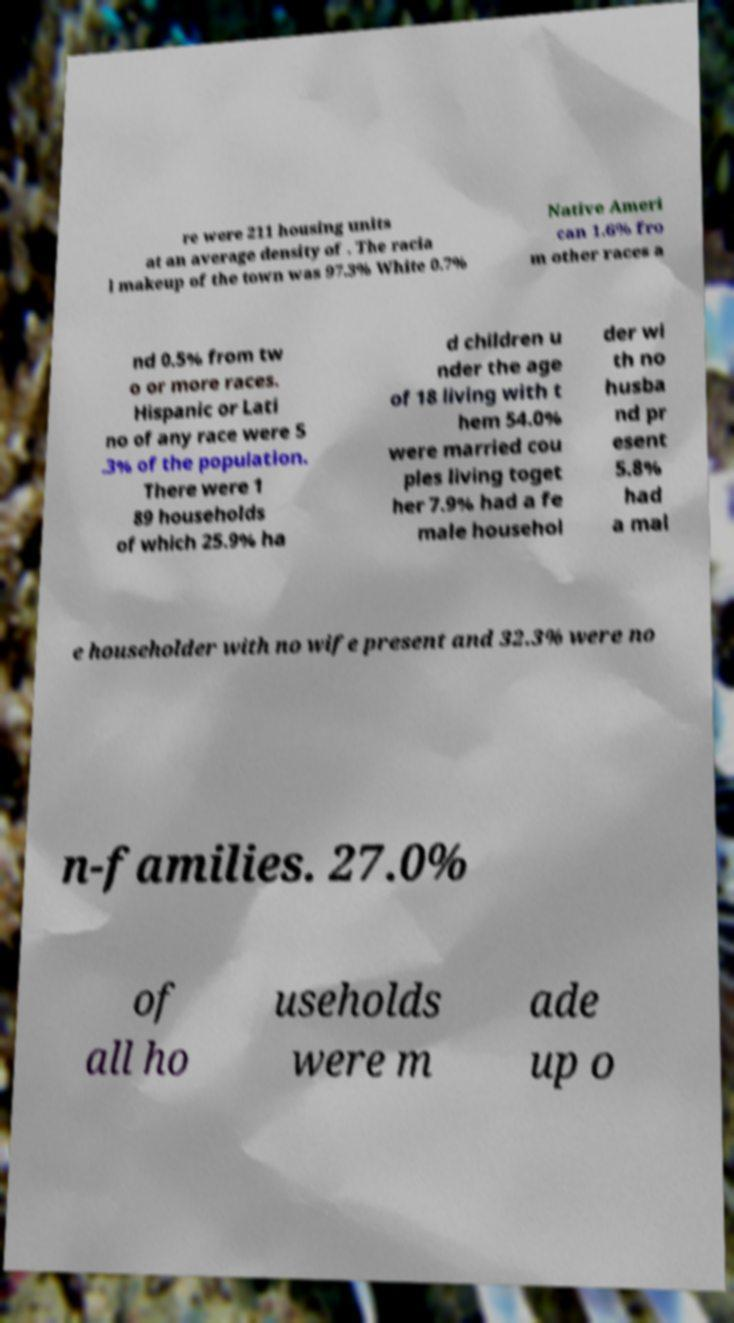There's text embedded in this image that I need extracted. Can you transcribe it verbatim? re were 211 housing units at an average density of . The racia l makeup of the town was 97.3% White 0.7% Native Ameri can 1.6% fro m other races a nd 0.5% from tw o or more races. Hispanic or Lati no of any race were 5 .3% of the population. There were 1 89 households of which 25.9% ha d children u nder the age of 18 living with t hem 54.0% were married cou ples living toget her 7.9% had a fe male househol der wi th no husba nd pr esent 5.8% had a mal e householder with no wife present and 32.3% were no n-families. 27.0% of all ho useholds were m ade up o 